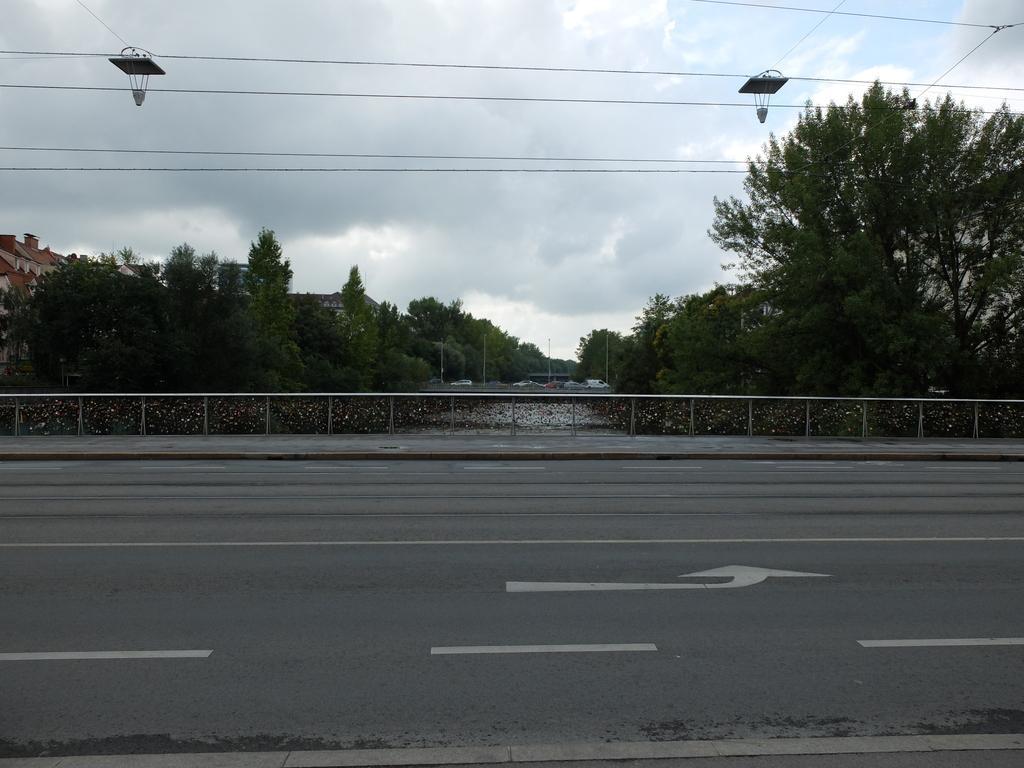How would you summarize this image in a sentence or two? In this aimeg, we can see the road, railings, trees, buildings, poles and vehicles. Background we can see the cloudy sky. Here we can see wires and few objects. 